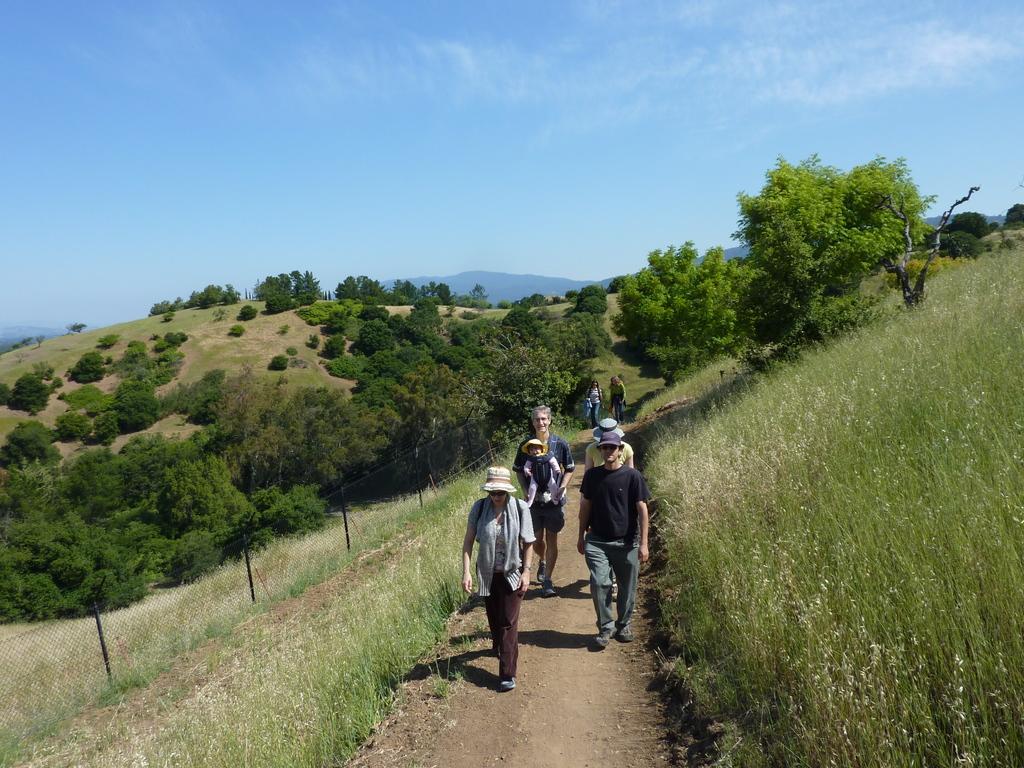Please provide a concise description of this image. In this image in the center there are some persons walking, on the right side and left side there are some plants, grass and in the background there are some trees and mountains. At the bottom there is walkway, and at the top of the image there is sky. 